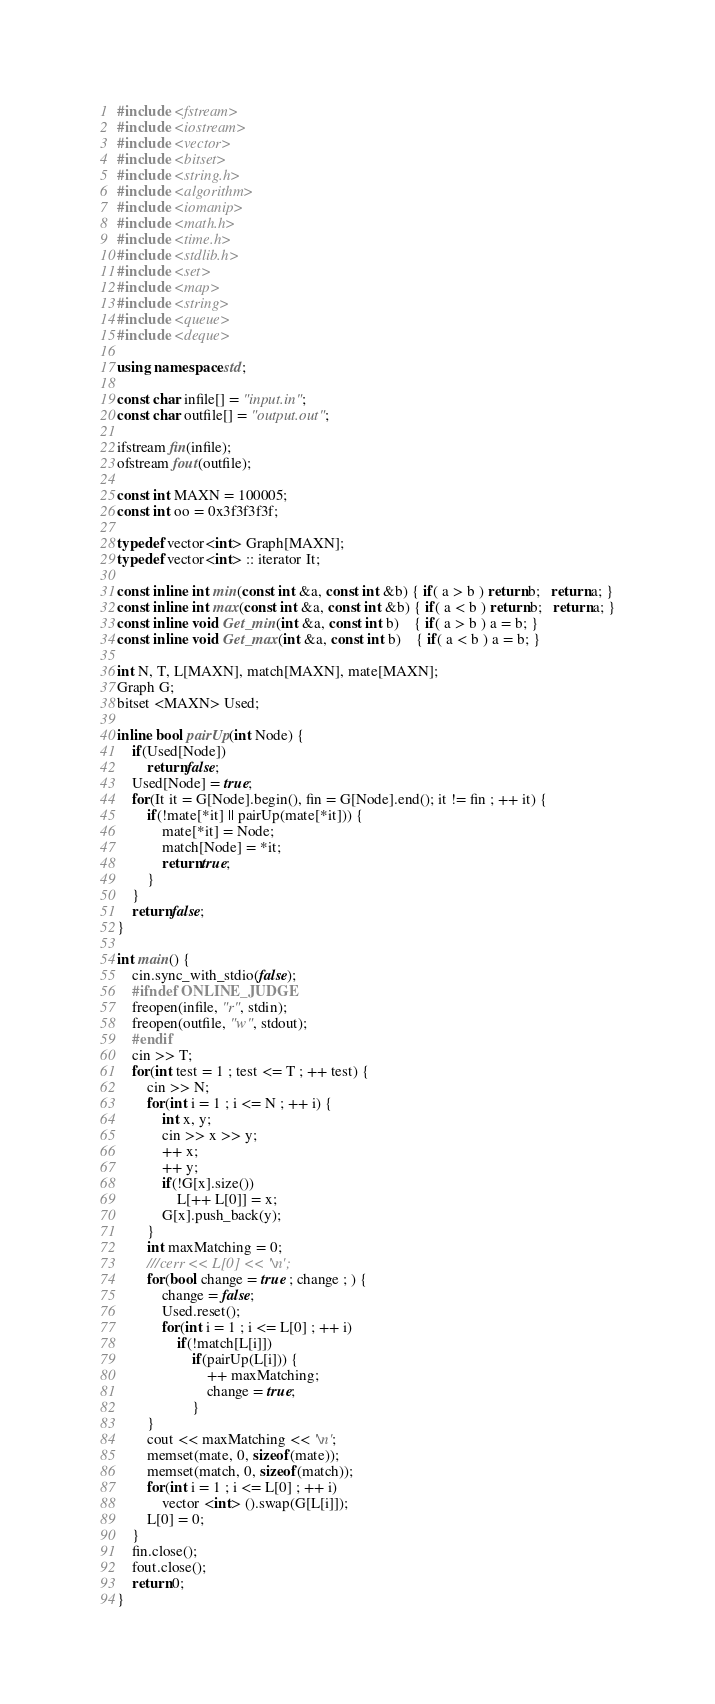Convert code to text. <code><loc_0><loc_0><loc_500><loc_500><_C++_>#include <fstream>
#include <iostream>
#include <vector>
#include <bitset>
#include <string.h>
#include <algorithm>
#include <iomanip>
#include <math.h>
#include <time.h>
#include <stdlib.h>
#include <set>
#include <map>
#include <string>
#include <queue>
#include <deque>

using namespace std;

const char infile[] = "input.in";
const char outfile[] = "output.out";

ifstream fin(infile);
ofstream fout(outfile);

const int MAXN = 100005;
const int oo = 0x3f3f3f3f;

typedef vector<int> Graph[MAXN];
typedef vector<int> :: iterator It;

const inline int min(const int &a, const int &b) { if( a > b ) return b;   return a; }
const inline int max(const int &a, const int &b) { if( a < b ) return b;   return a; }
const inline void Get_min(int &a, const int b)    { if( a > b ) a = b; }
const inline void Get_max(int &a, const int b)    { if( a < b ) a = b; }

int N, T, L[MAXN], match[MAXN], mate[MAXN];
Graph G;
bitset <MAXN> Used;

inline bool pairUp(int Node) {
    if(Used[Node])
        return false;
    Used[Node] = true;
    for(It it = G[Node].begin(), fin = G[Node].end(); it != fin ; ++ it) {
        if(!mate[*it] || pairUp(mate[*it])) {
            mate[*it] = Node;
            match[Node] = *it;
            return true;
        }
    }
    return false;
}

int main() {
    cin.sync_with_stdio(false);
    #ifndef ONLINE_JUDGE
    freopen(infile, "r", stdin);
    freopen(outfile, "w", stdout);
    #endif
    cin >> T;
    for(int test = 1 ; test <= T ; ++ test) {
        cin >> N;
        for(int i = 1 ; i <= N ; ++ i) {
            int x, y;
            cin >> x >> y;
            ++ x;
            ++ y;
            if(!G[x].size())
                L[++ L[0]] = x;
            G[x].push_back(y);
        }
        int maxMatching = 0;
        ///cerr << L[0] << '\n';
        for(bool change = true ; change ; ) {
            change = false;
            Used.reset();
            for(int i = 1 ; i <= L[0] ; ++ i)
                if(!match[L[i]])
                    if(pairUp(L[i])) {
                        ++ maxMatching;
                        change = true;
                    }
        }
        cout << maxMatching << '\n';
        memset(mate, 0, sizeof(mate));
        memset(match, 0, sizeof(match));
        for(int i = 1 ; i <= L[0] ; ++ i)
            vector <int> ().swap(G[L[i]]);
        L[0] = 0;
    }
    fin.close();
    fout.close();
    return 0;
}
</code> 